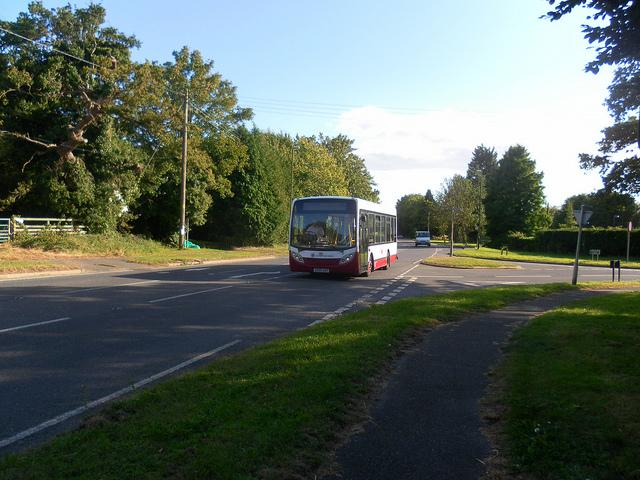Why is the windshield on the bus so large? visibility 